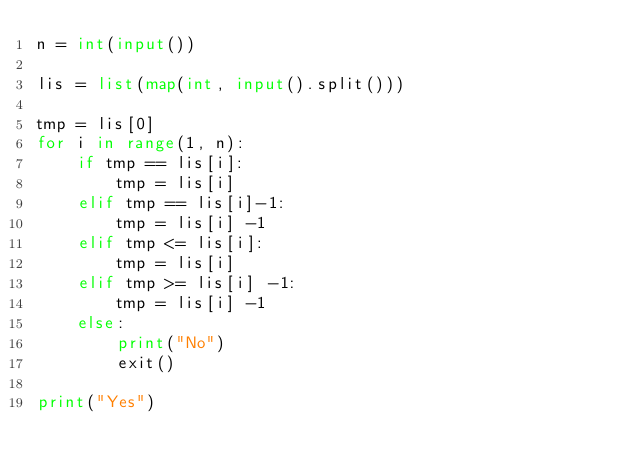Convert code to text. <code><loc_0><loc_0><loc_500><loc_500><_Python_>n = int(input())

lis = list(map(int, input().split()))

tmp = lis[0]
for i in range(1, n):
    if tmp == lis[i]:
        tmp = lis[i]
    elif tmp == lis[i]-1:
        tmp = lis[i] -1
    elif tmp <= lis[i]:
        tmp = lis[i]
    elif tmp >= lis[i] -1:
        tmp = lis[i] -1
    else:
        print("No")
        exit()
        
print("Yes")</code> 